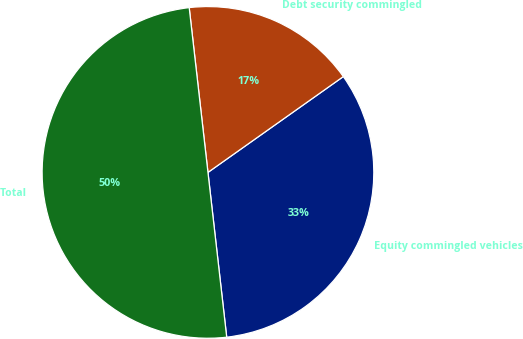<chart> <loc_0><loc_0><loc_500><loc_500><pie_chart><fcel>Equity commingled vehicles<fcel>Debt security commingled<fcel>Total<nl><fcel>33.0%<fcel>17.0%<fcel>50.0%<nl></chart> 